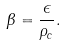Convert formula to latex. <formula><loc_0><loc_0><loc_500><loc_500>\beta = \frac { \epsilon } { { \rho } _ { c } } .</formula> 